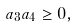<formula> <loc_0><loc_0><loc_500><loc_500>a _ { 3 } a _ { 4 } \geq 0 ,</formula> 